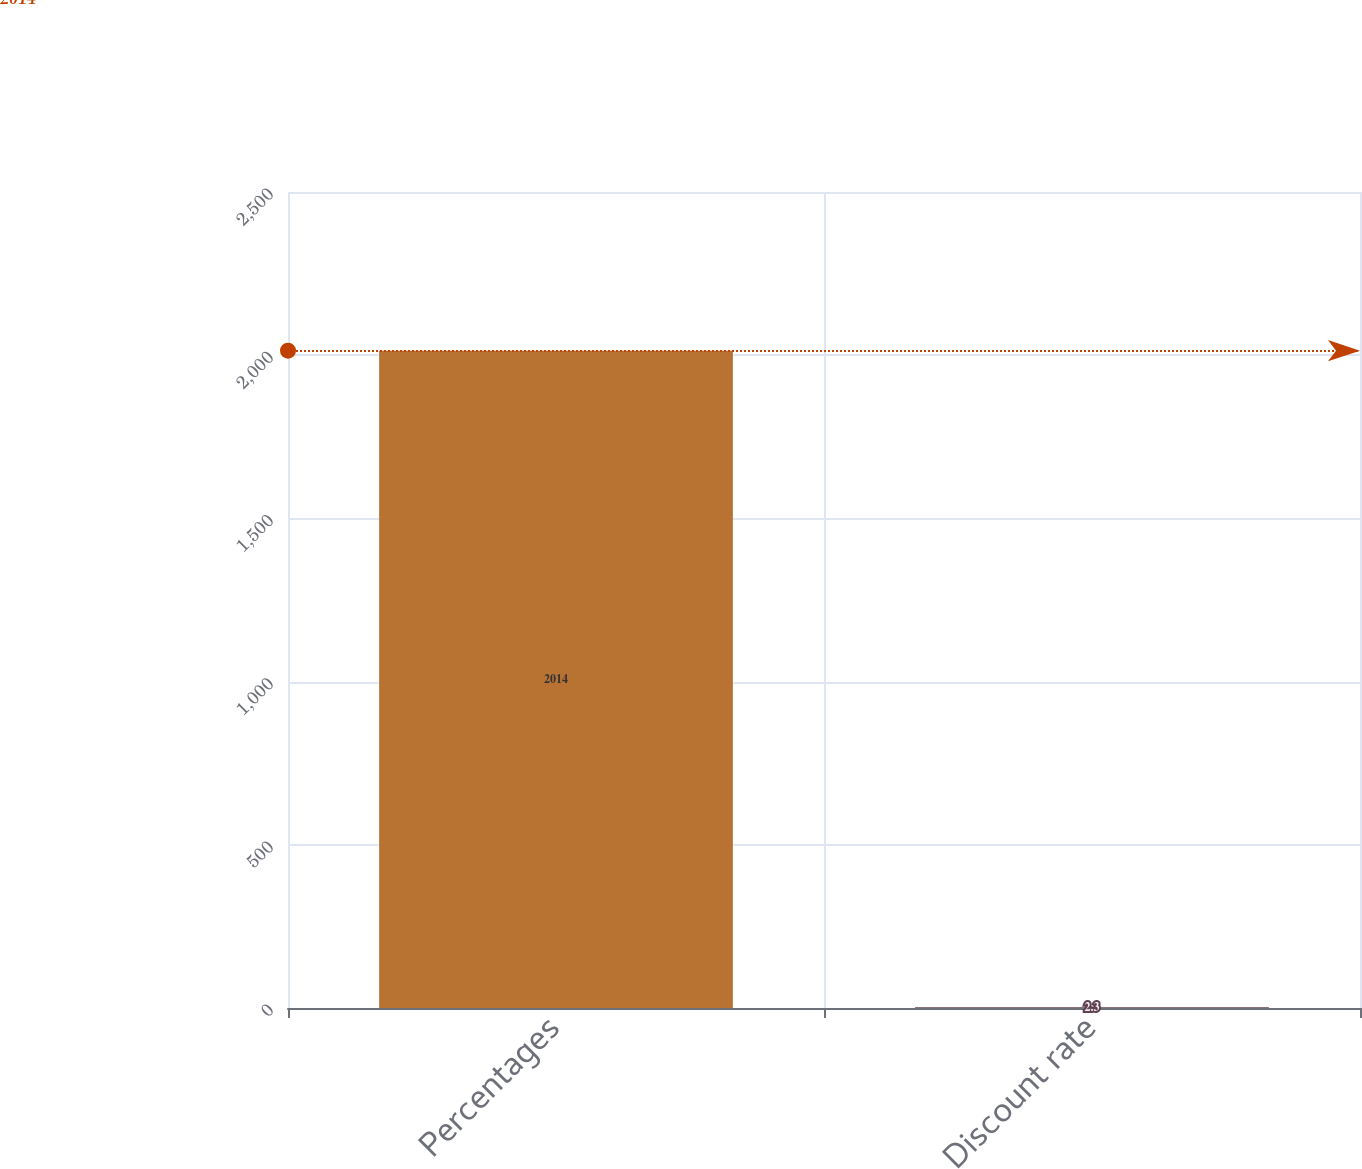Convert chart to OTSL. <chart><loc_0><loc_0><loc_500><loc_500><bar_chart><fcel>Percentages<fcel>Discount rate<nl><fcel>2014<fcel>2.3<nl></chart> 